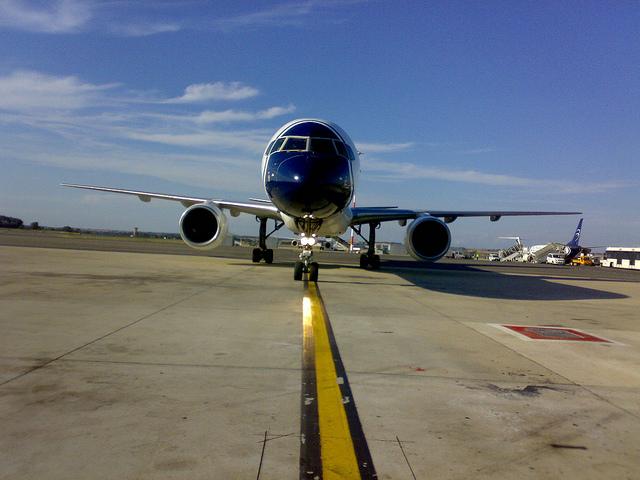Is the plane refueling?
Concise answer only. No. Is this plane in motion?
Concise answer only. No. What color is the line on the ground?
Be succinct. Yellow. 